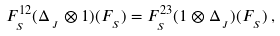Convert formula to latex. <formula><loc_0><loc_0><loc_500><loc_500>F _ { _ { S } } ^ { 1 2 } ( \Delta _ { _ { \, J } } \otimes 1 ) ( F _ { _ { \, S } } ) = F _ { _ { S } } ^ { 2 3 } ( 1 \otimes \Delta _ { _ { \, J } } ) ( F _ { _ { \, S } } ) \, ,</formula> 